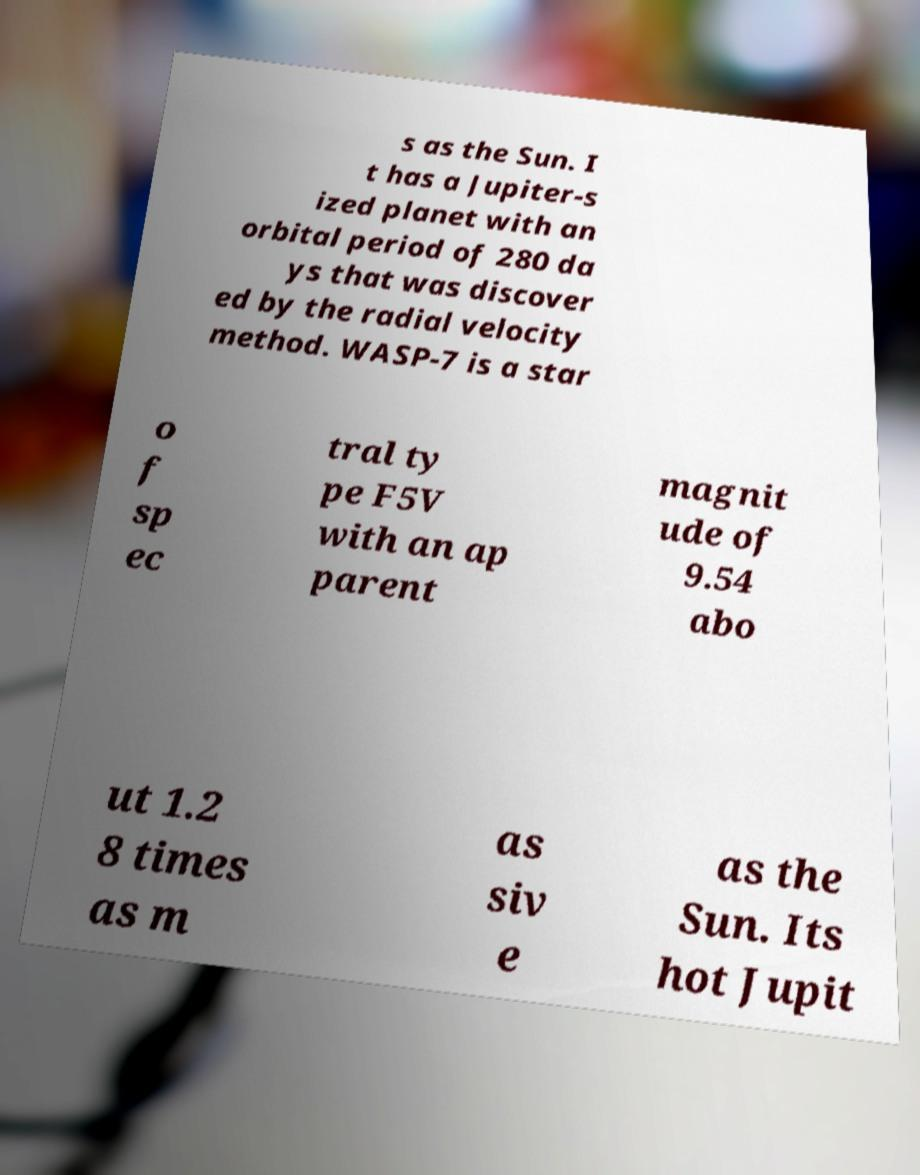Can you accurately transcribe the text from the provided image for me? s as the Sun. I t has a Jupiter-s ized planet with an orbital period of 280 da ys that was discover ed by the radial velocity method. WASP-7 is a star o f sp ec tral ty pe F5V with an ap parent magnit ude of 9.54 abo ut 1.2 8 times as m as siv e as the Sun. Its hot Jupit 